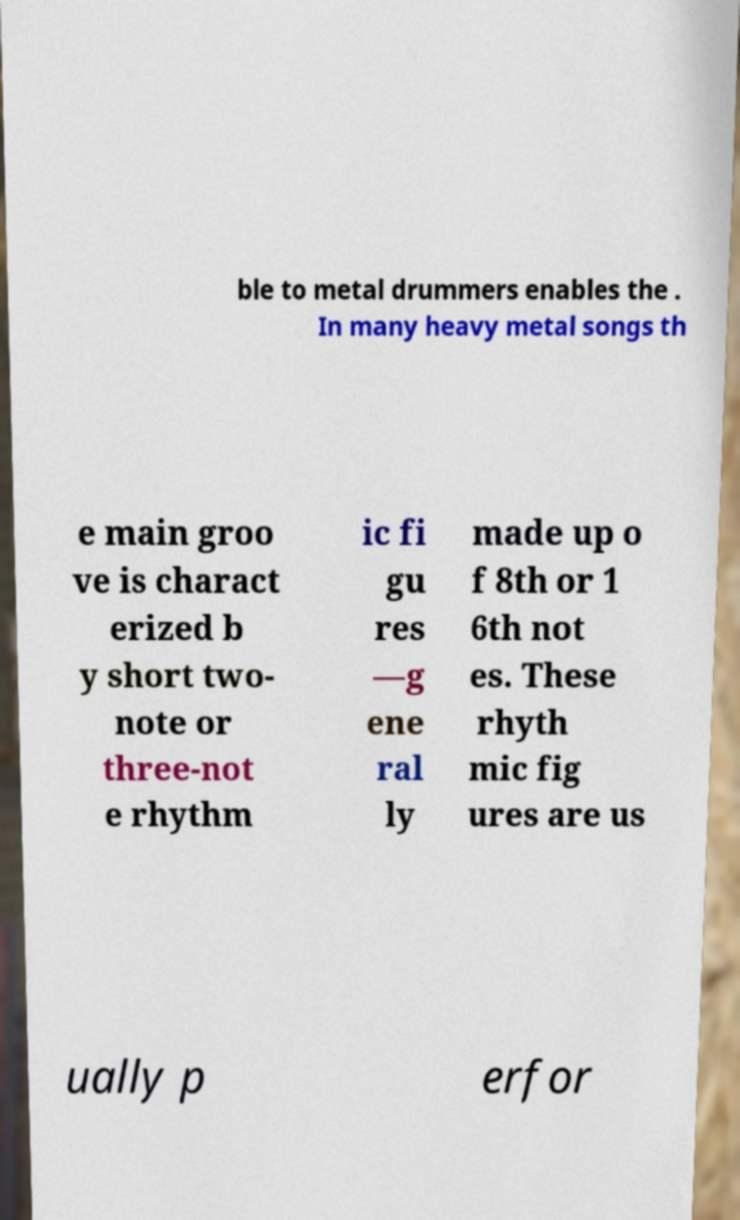I need the written content from this picture converted into text. Can you do that? ble to metal drummers enables the . In many heavy metal songs th e main groo ve is charact erized b y short two- note or three-not e rhythm ic fi gu res —g ene ral ly made up o f 8th or 1 6th not es. These rhyth mic fig ures are us ually p erfor 